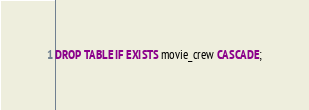<code> <loc_0><loc_0><loc_500><loc_500><_SQL_>DROP TABLE IF EXISTS movie_crew CASCADE;</code> 